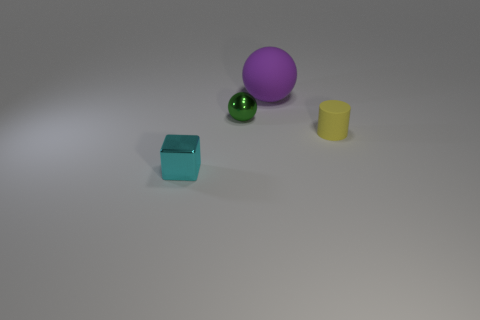How many other objects are there of the same shape as the big thing?
Make the answer very short. 1. Is the shape of the purple matte thing the same as the green object?
Give a very brief answer. Yes. There is a small matte thing; are there any small cylinders behind it?
Your answer should be very brief. No. What number of objects are big cyan rubber blocks or balls?
Ensure brevity in your answer.  2. How many other things are the same size as the shiny sphere?
Offer a terse response. 2. How many objects are behind the tiny cube and to the left of the tiny cylinder?
Offer a terse response. 2. There is a ball in front of the purple ball; is it the same size as the matte object behind the yellow object?
Ensure brevity in your answer.  No. There is a sphere that is to the left of the large purple rubber ball; what size is it?
Ensure brevity in your answer.  Small. What number of things are either tiny objects that are to the right of the cyan object or small shiny things that are on the left side of the green sphere?
Provide a short and direct response. 3. Is the number of small blocks that are behind the green shiny thing the same as the number of cyan blocks behind the cyan metallic block?
Ensure brevity in your answer.  Yes. 